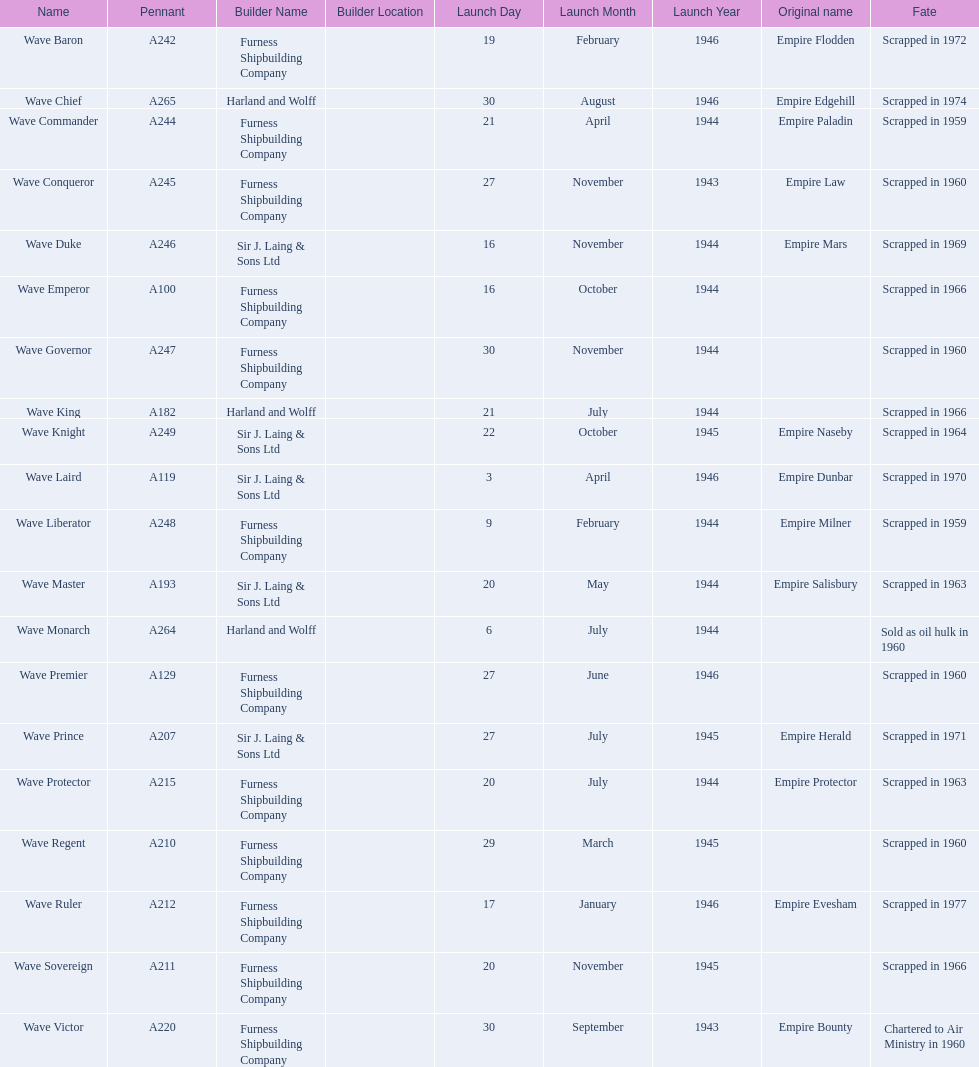What date was the wave victor launched? 30 September 1943. What other oiler was launched that same year? Wave Conqueror. 